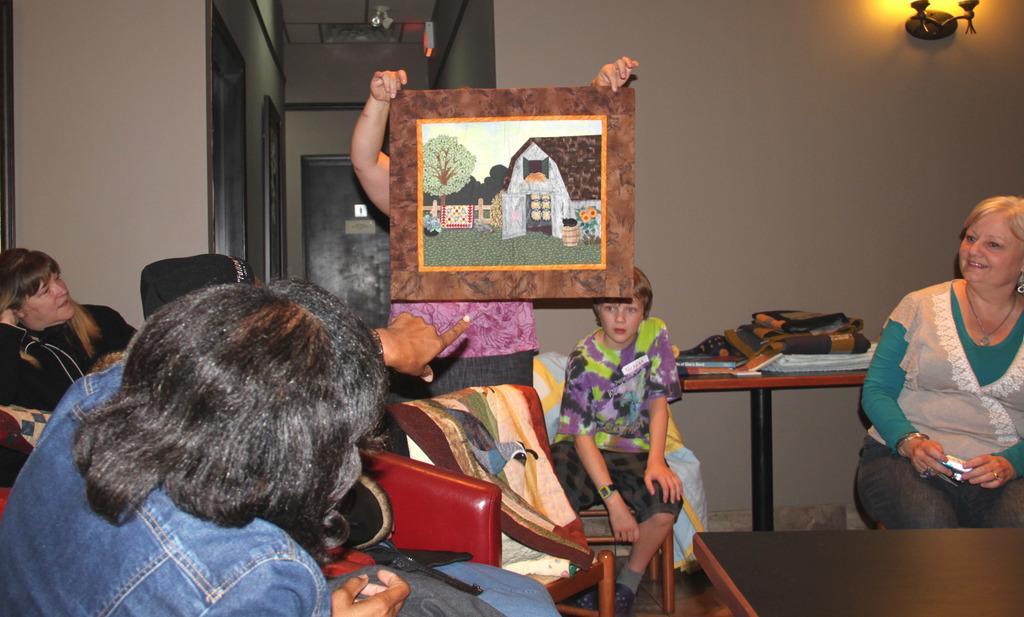Please provide a concise description of this image. The picture is taken inside a house. In the foreground of the picture we can see people, couches, tables, clothes and various other objects. In the middle of the picture we can see a person holding a frame. On the right it is well. On the left it is well. In the center of the background we can see doors. 